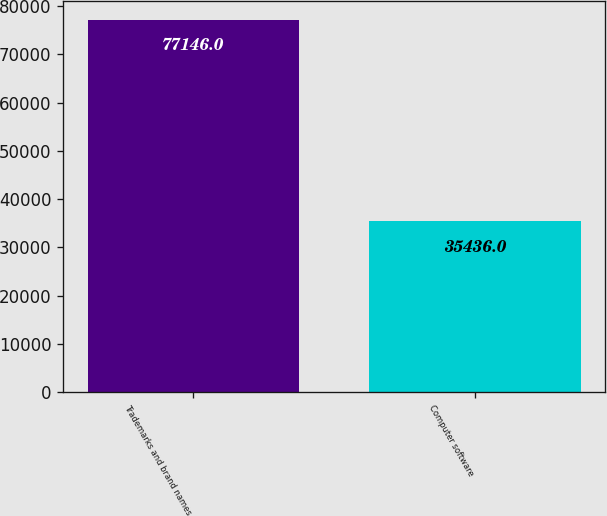Convert chart. <chart><loc_0><loc_0><loc_500><loc_500><bar_chart><fcel>Trademarks and brand names<fcel>Computer software<nl><fcel>77146<fcel>35436<nl></chart> 